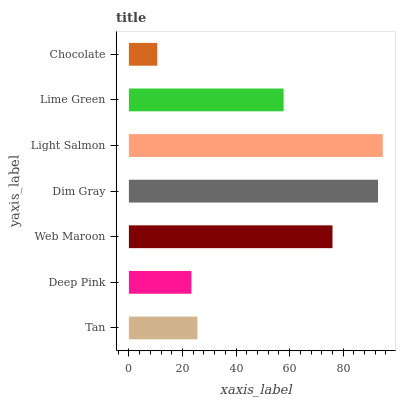Is Chocolate the minimum?
Answer yes or no. Yes. Is Light Salmon the maximum?
Answer yes or no. Yes. Is Deep Pink the minimum?
Answer yes or no. No. Is Deep Pink the maximum?
Answer yes or no. No. Is Tan greater than Deep Pink?
Answer yes or no. Yes. Is Deep Pink less than Tan?
Answer yes or no. Yes. Is Deep Pink greater than Tan?
Answer yes or no. No. Is Tan less than Deep Pink?
Answer yes or no. No. Is Lime Green the high median?
Answer yes or no. Yes. Is Lime Green the low median?
Answer yes or no. Yes. Is Tan the high median?
Answer yes or no. No. Is Chocolate the low median?
Answer yes or no. No. 